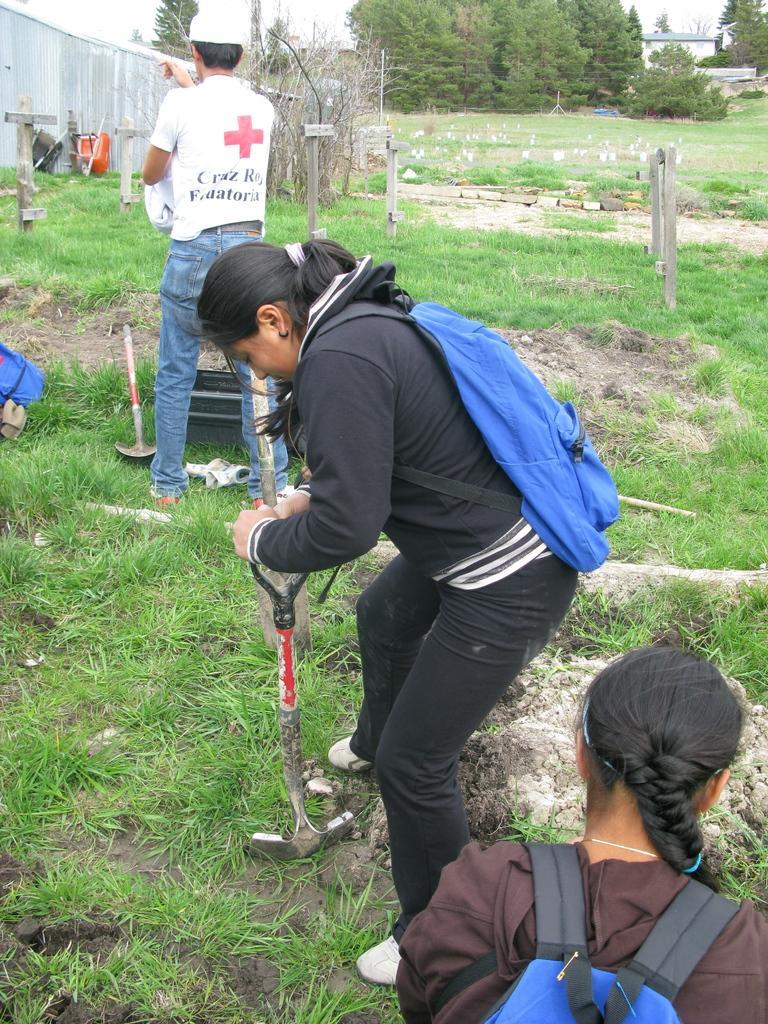Please provide a concise description of this image. In this image I can see an open grass ground and on it I can see three persons and in the front I can see two of them are carrying blue colour bags and one of them is holding a shovel. In the background I can see number of poles, number of trees, buildings and on the left side I can see a blue colour bag and a shovel on the ground. I can also see few other things on the top left side of this image. 